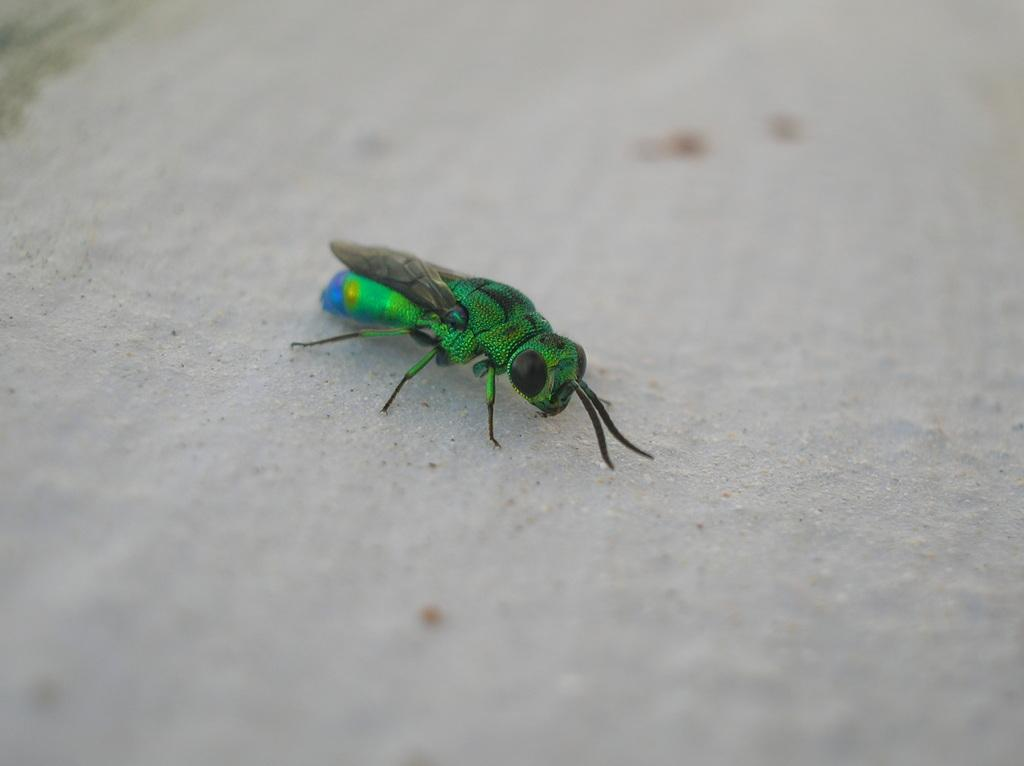What type of creature is present in the image? There is an insect in the image. What colors can be seen on the insect? The insect has green, blue, and black colors. What is the color of the background in the image? The background of the image is white. What type of smile can be seen on the insect's face in the image? There is no smile present on the insect's face in the image, as insects do not have facial expressions. 